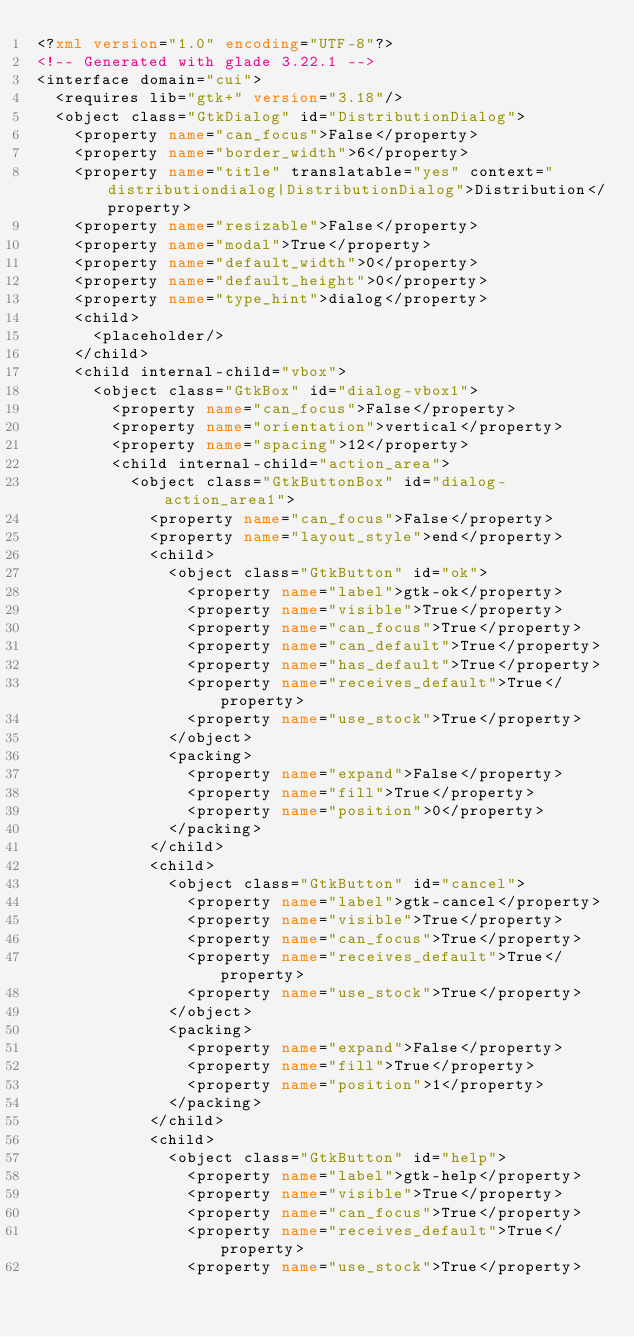<code> <loc_0><loc_0><loc_500><loc_500><_XML_><?xml version="1.0" encoding="UTF-8"?>
<!-- Generated with glade 3.22.1 -->
<interface domain="cui">
  <requires lib="gtk+" version="3.18"/>
  <object class="GtkDialog" id="DistributionDialog">
    <property name="can_focus">False</property>
    <property name="border_width">6</property>
    <property name="title" translatable="yes" context="distributiondialog|DistributionDialog">Distribution</property>
    <property name="resizable">False</property>
    <property name="modal">True</property>
    <property name="default_width">0</property>
    <property name="default_height">0</property>
    <property name="type_hint">dialog</property>
    <child>
      <placeholder/>
    </child>
    <child internal-child="vbox">
      <object class="GtkBox" id="dialog-vbox1">
        <property name="can_focus">False</property>
        <property name="orientation">vertical</property>
        <property name="spacing">12</property>
        <child internal-child="action_area">
          <object class="GtkButtonBox" id="dialog-action_area1">
            <property name="can_focus">False</property>
            <property name="layout_style">end</property>
            <child>
              <object class="GtkButton" id="ok">
                <property name="label">gtk-ok</property>
                <property name="visible">True</property>
                <property name="can_focus">True</property>
                <property name="can_default">True</property>
                <property name="has_default">True</property>
                <property name="receives_default">True</property>
                <property name="use_stock">True</property>
              </object>
              <packing>
                <property name="expand">False</property>
                <property name="fill">True</property>
                <property name="position">0</property>
              </packing>
            </child>
            <child>
              <object class="GtkButton" id="cancel">
                <property name="label">gtk-cancel</property>
                <property name="visible">True</property>
                <property name="can_focus">True</property>
                <property name="receives_default">True</property>
                <property name="use_stock">True</property>
              </object>
              <packing>
                <property name="expand">False</property>
                <property name="fill">True</property>
                <property name="position">1</property>
              </packing>
            </child>
            <child>
              <object class="GtkButton" id="help">
                <property name="label">gtk-help</property>
                <property name="visible">True</property>
                <property name="can_focus">True</property>
                <property name="receives_default">True</property>
                <property name="use_stock">True</property></code> 